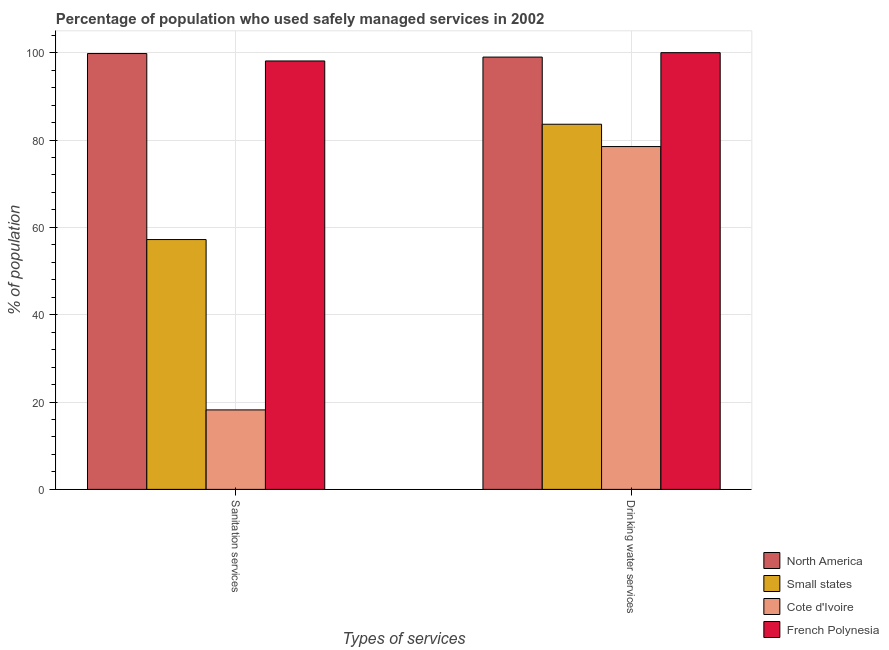How many different coloured bars are there?
Offer a very short reply. 4. Are the number of bars per tick equal to the number of legend labels?
Offer a terse response. Yes. How many bars are there on the 1st tick from the left?
Your answer should be compact. 4. How many bars are there on the 1st tick from the right?
Make the answer very short. 4. What is the label of the 1st group of bars from the left?
Your answer should be compact. Sanitation services. What is the percentage of population who used drinking water services in North America?
Ensure brevity in your answer.  98.99. Across all countries, what is the maximum percentage of population who used sanitation services?
Keep it short and to the point. 99.8. Across all countries, what is the minimum percentage of population who used drinking water services?
Offer a terse response. 78.5. In which country was the percentage of population who used sanitation services maximum?
Provide a succinct answer. North America. In which country was the percentage of population who used sanitation services minimum?
Offer a very short reply. Cote d'Ivoire. What is the total percentage of population who used drinking water services in the graph?
Make the answer very short. 361.1. What is the difference between the percentage of population who used sanitation services in Small states and that in Cote d'Ivoire?
Offer a terse response. 39.01. What is the difference between the percentage of population who used drinking water services in North America and the percentage of population who used sanitation services in Small states?
Offer a terse response. 41.78. What is the average percentage of population who used drinking water services per country?
Provide a succinct answer. 90.27. What is the difference between the percentage of population who used sanitation services and percentage of population who used drinking water services in Cote d'Ivoire?
Provide a succinct answer. -60.3. In how many countries, is the percentage of population who used drinking water services greater than 76 %?
Provide a succinct answer. 4. What is the ratio of the percentage of population who used sanitation services in Small states to that in North America?
Your answer should be compact. 0.57. In how many countries, is the percentage of population who used drinking water services greater than the average percentage of population who used drinking water services taken over all countries?
Your response must be concise. 2. What does the 3rd bar from the left in Drinking water services represents?
Your answer should be compact. Cote d'Ivoire. What does the 1st bar from the right in Drinking water services represents?
Provide a succinct answer. French Polynesia. How many bars are there?
Provide a succinct answer. 8. What is the difference between two consecutive major ticks on the Y-axis?
Make the answer very short. 20. Are the values on the major ticks of Y-axis written in scientific E-notation?
Make the answer very short. No. Does the graph contain any zero values?
Offer a terse response. No. How are the legend labels stacked?
Keep it short and to the point. Vertical. What is the title of the graph?
Provide a succinct answer. Percentage of population who used safely managed services in 2002. Does "Bhutan" appear as one of the legend labels in the graph?
Your answer should be very brief. No. What is the label or title of the X-axis?
Make the answer very short. Types of services. What is the label or title of the Y-axis?
Offer a terse response. % of population. What is the % of population of North America in Sanitation services?
Your response must be concise. 99.8. What is the % of population of Small states in Sanitation services?
Provide a short and direct response. 57.21. What is the % of population in Cote d'Ivoire in Sanitation services?
Your response must be concise. 18.2. What is the % of population in French Polynesia in Sanitation services?
Offer a very short reply. 98.1. What is the % of population in North America in Drinking water services?
Your answer should be compact. 98.99. What is the % of population in Small states in Drinking water services?
Make the answer very short. 83.61. What is the % of population in Cote d'Ivoire in Drinking water services?
Your answer should be compact. 78.5. Across all Types of services, what is the maximum % of population of North America?
Ensure brevity in your answer.  99.8. Across all Types of services, what is the maximum % of population in Small states?
Provide a succinct answer. 83.61. Across all Types of services, what is the maximum % of population of Cote d'Ivoire?
Provide a succinct answer. 78.5. Across all Types of services, what is the minimum % of population of North America?
Provide a short and direct response. 98.99. Across all Types of services, what is the minimum % of population in Small states?
Provide a succinct answer. 57.21. Across all Types of services, what is the minimum % of population of French Polynesia?
Your answer should be compact. 98.1. What is the total % of population of North America in the graph?
Your answer should be compact. 198.79. What is the total % of population of Small states in the graph?
Your response must be concise. 140.82. What is the total % of population of Cote d'Ivoire in the graph?
Make the answer very short. 96.7. What is the total % of population in French Polynesia in the graph?
Give a very brief answer. 198.1. What is the difference between the % of population of North America in Sanitation services and that in Drinking water services?
Your answer should be very brief. 0.81. What is the difference between the % of population in Small states in Sanitation services and that in Drinking water services?
Give a very brief answer. -26.4. What is the difference between the % of population of Cote d'Ivoire in Sanitation services and that in Drinking water services?
Make the answer very short. -60.3. What is the difference between the % of population of North America in Sanitation services and the % of population of Small states in Drinking water services?
Keep it short and to the point. 16.19. What is the difference between the % of population of North America in Sanitation services and the % of population of Cote d'Ivoire in Drinking water services?
Keep it short and to the point. 21.3. What is the difference between the % of population of North America in Sanitation services and the % of population of French Polynesia in Drinking water services?
Offer a very short reply. -0.2. What is the difference between the % of population of Small states in Sanitation services and the % of population of Cote d'Ivoire in Drinking water services?
Provide a succinct answer. -21.29. What is the difference between the % of population of Small states in Sanitation services and the % of population of French Polynesia in Drinking water services?
Provide a succinct answer. -42.79. What is the difference between the % of population of Cote d'Ivoire in Sanitation services and the % of population of French Polynesia in Drinking water services?
Your response must be concise. -81.8. What is the average % of population in North America per Types of services?
Offer a terse response. 99.39. What is the average % of population of Small states per Types of services?
Provide a short and direct response. 70.41. What is the average % of population of Cote d'Ivoire per Types of services?
Your answer should be compact. 48.35. What is the average % of population in French Polynesia per Types of services?
Your response must be concise. 99.05. What is the difference between the % of population in North America and % of population in Small states in Sanitation services?
Your answer should be compact. 42.59. What is the difference between the % of population of North America and % of population of Cote d'Ivoire in Sanitation services?
Offer a very short reply. 81.6. What is the difference between the % of population in Small states and % of population in Cote d'Ivoire in Sanitation services?
Ensure brevity in your answer.  39.01. What is the difference between the % of population of Small states and % of population of French Polynesia in Sanitation services?
Offer a terse response. -40.89. What is the difference between the % of population in Cote d'Ivoire and % of population in French Polynesia in Sanitation services?
Ensure brevity in your answer.  -79.9. What is the difference between the % of population of North America and % of population of Small states in Drinking water services?
Make the answer very short. 15.38. What is the difference between the % of population in North America and % of population in Cote d'Ivoire in Drinking water services?
Your answer should be very brief. 20.49. What is the difference between the % of population in North America and % of population in French Polynesia in Drinking water services?
Keep it short and to the point. -1.01. What is the difference between the % of population in Small states and % of population in Cote d'Ivoire in Drinking water services?
Offer a very short reply. 5.11. What is the difference between the % of population of Small states and % of population of French Polynesia in Drinking water services?
Offer a very short reply. -16.39. What is the difference between the % of population of Cote d'Ivoire and % of population of French Polynesia in Drinking water services?
Ensure brevity in your answer.  -21.5. What is the ratio of the % of population in North America in Sanitation services to that in Drinking water services?
Your response must be concise. 1.01. What is the ratio of the % of population in Small states in Sanitation services to that in Drinking water services?
Keep it short and to the point. 0.68. What is the ratio of the % of population of Cote d'Ivoire in Sanitation services to that in Drinking water services?
Offer a very short reply. 0.23. What is the ratio of the % of population of French Polynesia in Sanitation services to that in Drinking water services?
Offer a very short reply. 0.98. What is the difference between the highest and the second highest % of population of North America?
Provide a short and direct response. 0.81. What is the difference between the highest and the second highest % of population of Small states?
Your answer should be compact. 26.4. What is the difference between the highest and the second highest % of population of Cote d'Ivoire?
Give a very brief answer. 60.3. What is the difference between the highest and the second highest % of population in French Polynesia?
Offer a terse response. 1.9. What is the difference between the highest and the lowest % of population of North America?
Offer a very short reply. 0.81. What is the difference between the highest and the lowest % of population in Small states?
Provide a short and direct response. 26.4. What is the difference between the highest and the lowest % of population of Cote d'Ivoire?
Your answer should be compact. 60.3. 